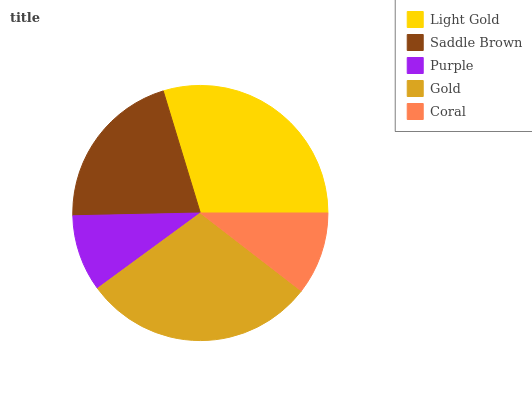Is Purple the minimum?
Answer yes or no. Yes. Is Light Gold the maximum?
Answer yes or no. Yes. Is Saddle Brown the minimum?
Answer yes or no. No. Is Saddle Brown the maximum?
Answer yes or no. No. Is Light Gold greater than Saddle Brown?
Answer yes or no. Yes. Is Saddle Brown less than Light Gold?
Answer yes or no. Yes. Is Saddle Brown greater than Light Gold?
Answer yes or no. No. Is Light Gold less than Saddle Brown?
Answer yes or no. No. Is Saddle Brown the high median?
Answer yes or no. Yes. Is Saddle Brown the low median?
Answer yes or no. Yes. Is Coral the high median?
Answer yes or no. No. Is Gold the low median?
Answer yes or no. No. 